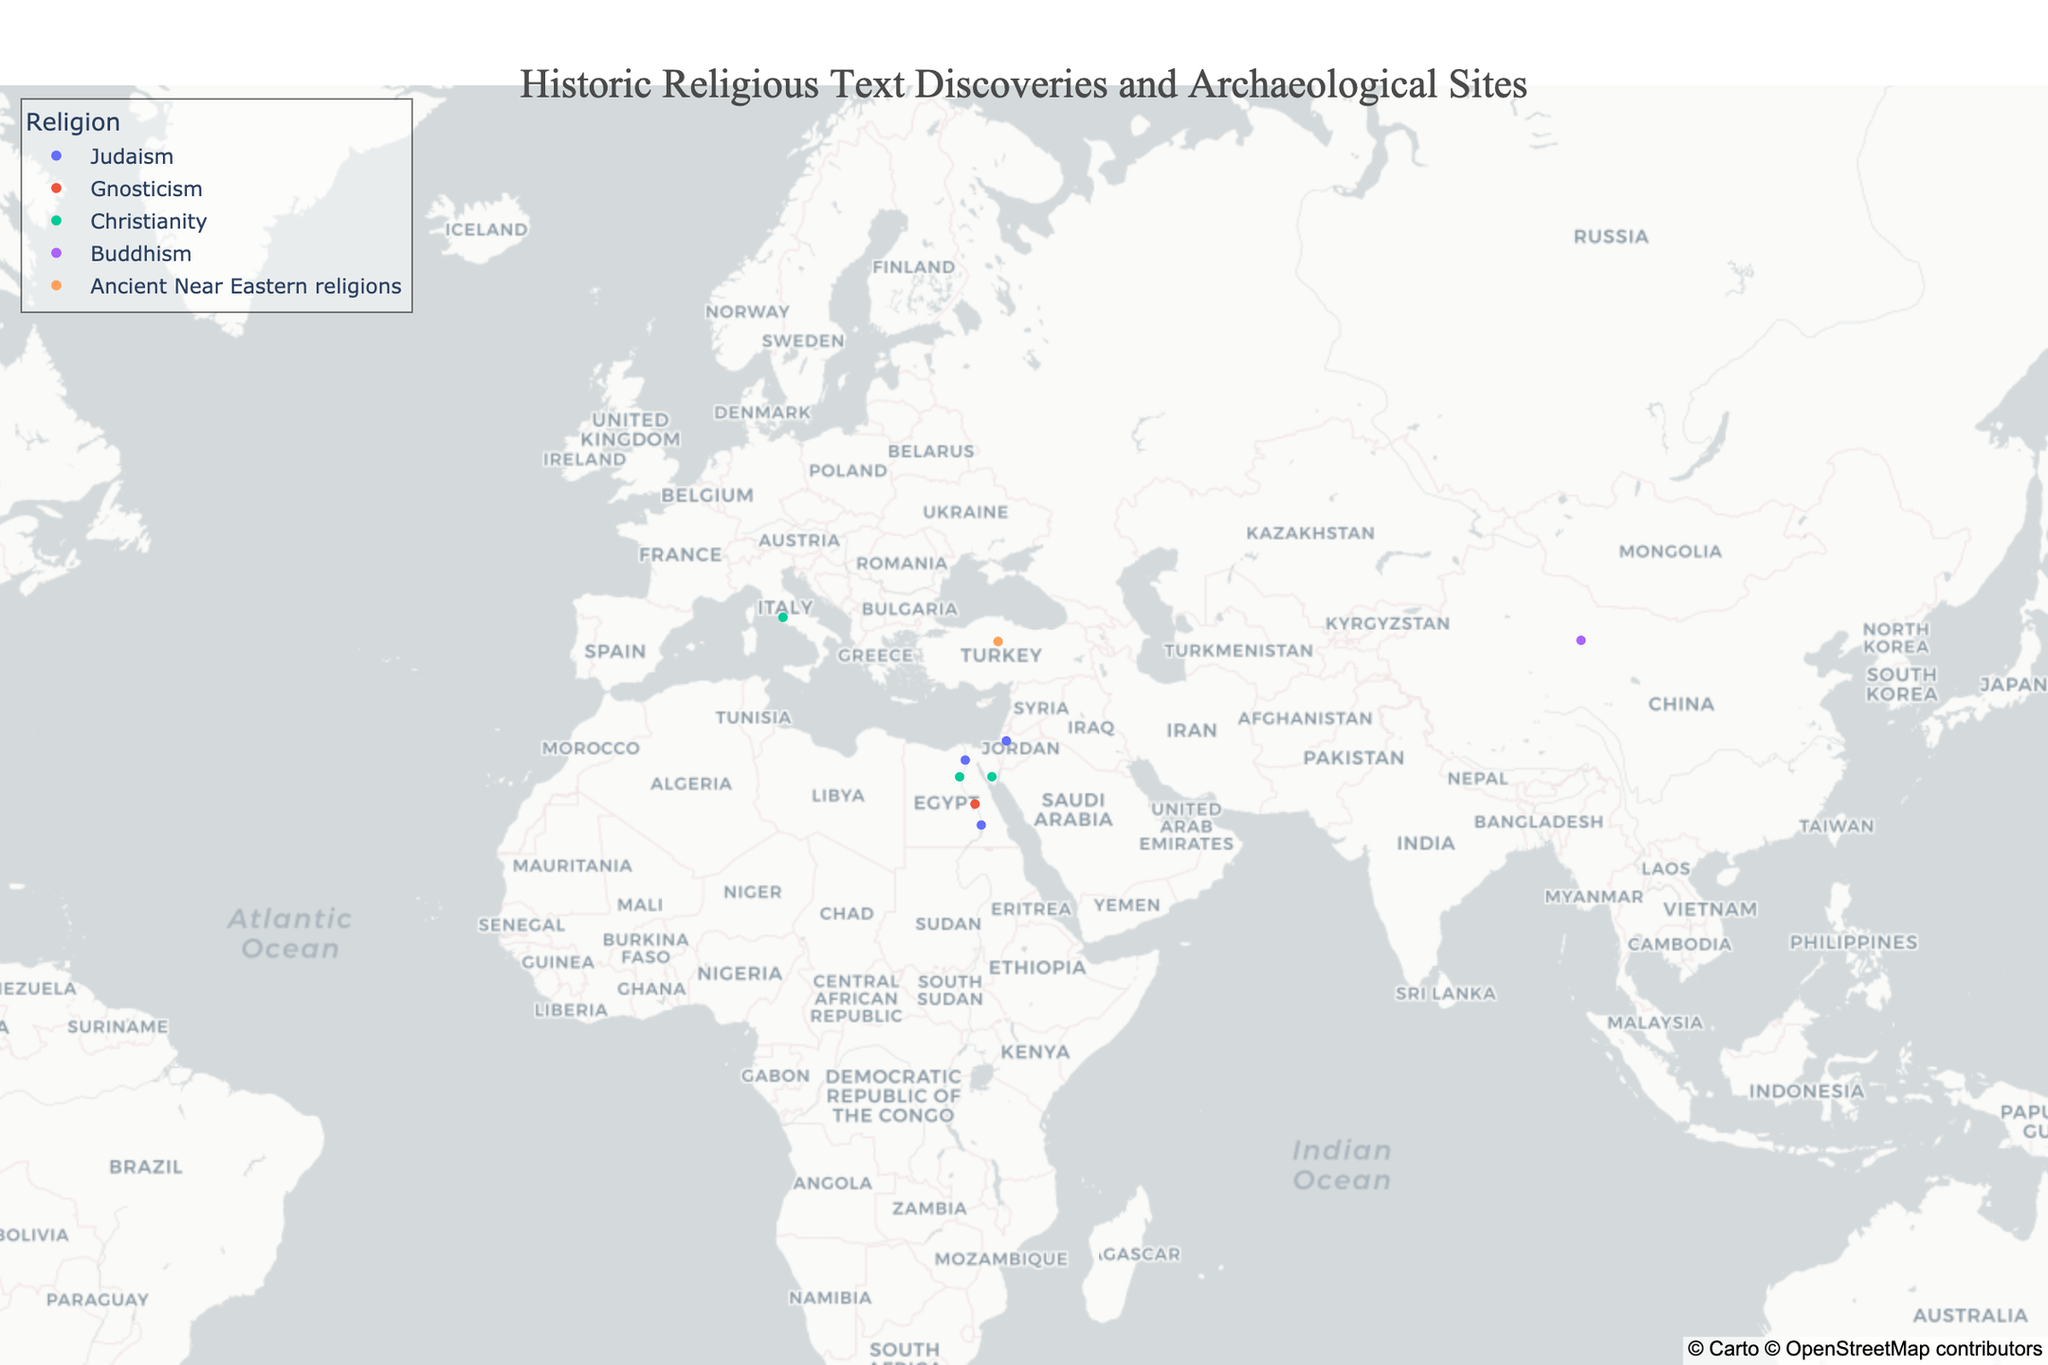What is the title of the figure? The title can be found at the top center of the figure.
Answer: Historic Religious Text Discoveries and Archaeological Sites Which religions are represented in the figure? The legend on the right side of the figure lists the religions represented.
Answer: Judaism, Gnosticism, Christianity, Buddhism, Ancient Near Eastern religions Which site is located furthest north? By analyzing the latitude values (positioning on the map), the site with the highest latitude is identified.
Answer: Vatican City How many sites are associated with Christianity? The number of markers on the map with the color corresponding to Christianity is counted.
Answer: Three (Oxyrhynchus, Mount Sinai, Vatican City) Which religious text was discovered first, the Dead Sea Scrolls or the Nag Hammadi library? Compare the year of discovery for the Dead Sea Scrolls (1947) and the Nag Hammadi library (1945).
Answer: Nag Hammadi library Which site represents the discovery of texts from Buddhism? Hover over the markers to get the details or refer to the legend and data points.
Answer: Dunhuang What is the average year of discovery for all displayed sites? Calculate the average of all the numeric years mentioned: (1947 + 1945 + 1896 + 1844 + 1900 + 15c + 1896 + 1906 + 1893 + 1906). For the Codex Vaticanus, assume around 1500. Summing these years and dividing by the number of sites (10) will give the average.
Answer: ~(1932 + 1500)/10 = 1882.2 Which site has the closest proximity to Mount Sinai? Compare the latitudes and longitudes of all sites with Mount Sinai (28.5456, 33.9756); the closest proximity would be identified based on geographical proximity.
Answer: Oxyrhynchus Which religious text discoveries are located in Egypt? From the provided data, locate the sites in Egypt and identify the texts associated with those sites.
Answer: Nag Hammadi, Oxyrhynchus, Cairo Geniza, Elephantine 